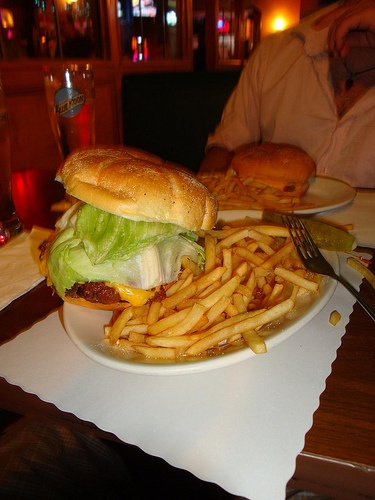Describe the objects in this image and their specific colors. I can see dining table in maroon, black, darkgray, and lightgray tones, sandwich in maroon, brown, olive, and tan tones, people in maroon, brown, and black tones, cup in maroon, black, and gray tones, and cup in maroon and red tones in this image. 